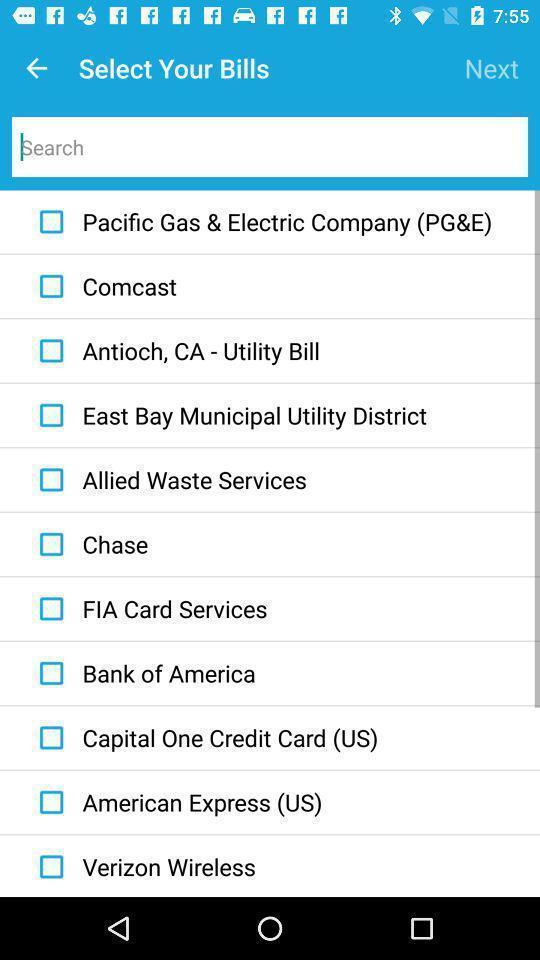Describe the visual elements of this screenshot. Select the option to pay bills. 